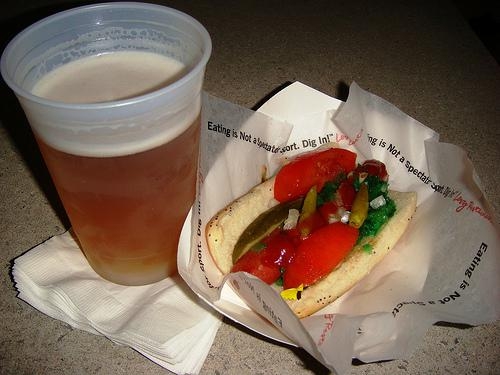Question: what is in the cup?
Choices:
A. Water.
B. Wine.
C. Soda.
D. Beer.
Answer with the letter. Answer: D Question: what is in the paper bowl?
Choices:
A. Sandwich.
B. Soup.
C. Salad.
D. Pasta.
Answer with the letter. Answer: A Question: how is the beer served?
Choices:
A. In a plastic cup.
B. In a glass.
C. In a jar.
D. From a coffee cup.
Answer with the letter. Answer: A Question: what is on the hot dog?
Choices:
A. Relish and mustard.
B. Ketchup and mayonnaise.
C. Pickles and tomatoes.
D. Onions and chili.
Answer with the letter. Answer: C 